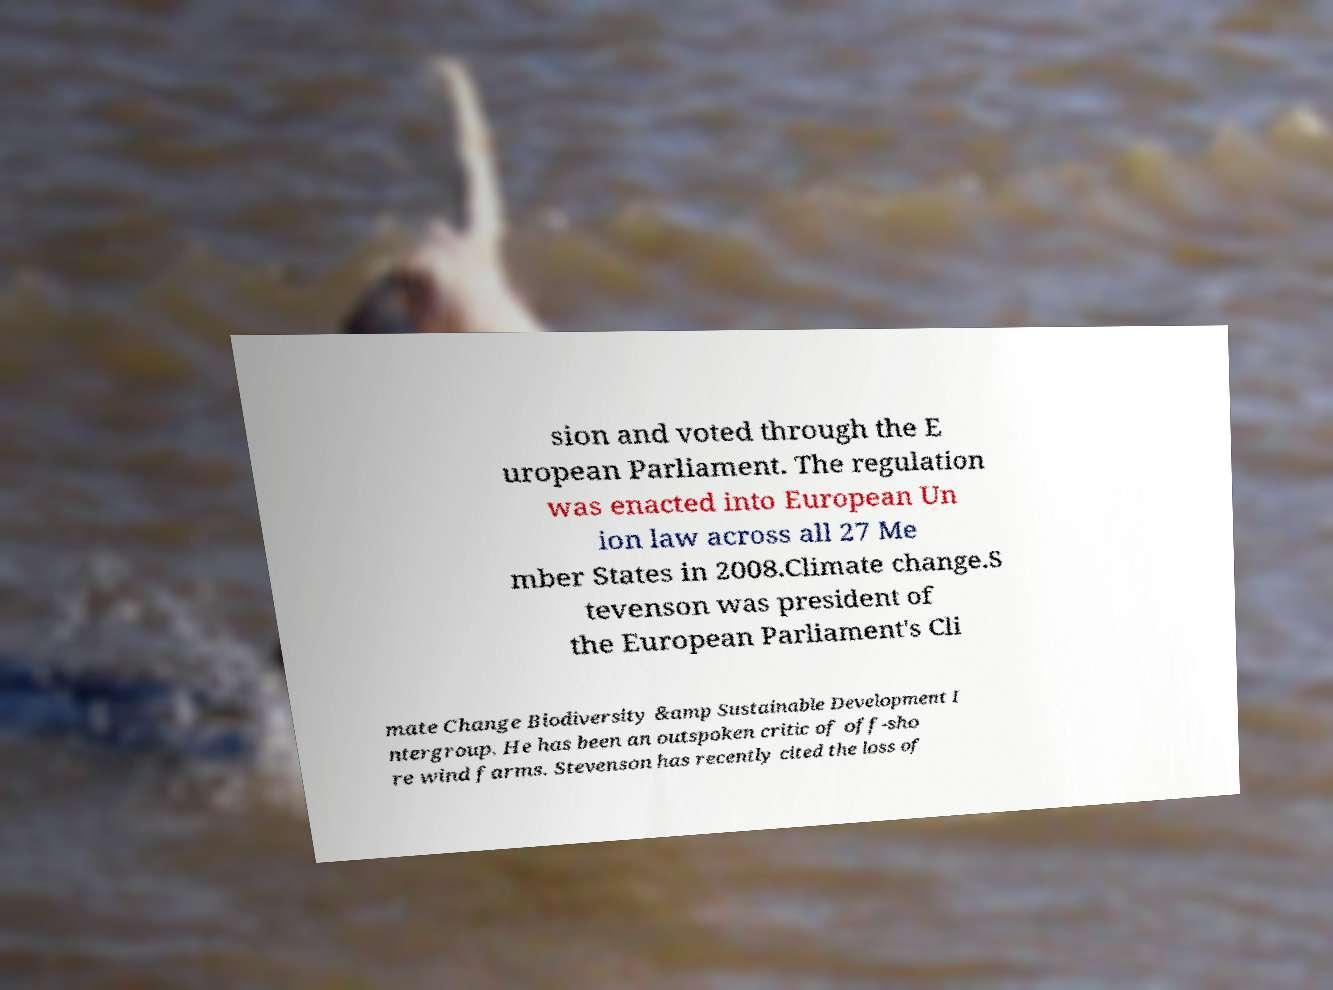Could you extract and type out the text from this image? sion and voted through the E uropean Parliament. The regulation was enacted into European Un ion law across all 27 Me mber States in 2008.Climate change.S tevenson was president of the European Parliament's Cli mate Change Biodiversity &amp Sustainable Development I ntergroup. He has been an outspoken critic of off-sho re wind farms. Stevenson has recently cited the loss of 